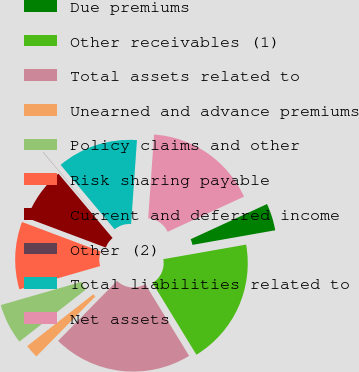Convert chart. <chart><loc_0><loc_0><loc_500><loc_500><pie_chart><fcel>Due premiums<fcel>Other receivables (1)<fcel>Total assets related to<fcel>Unearned and advance premiums<fcel>Policy claims and other<fcel>Risk sharing payable<fcel>Current and deferred income<fcel>Other (2)<fcel>Total liabilities related to<fcel>Net assets<nl><fcel>4.09%<fcel>19.05%<fcel>21.08%<fcel>2.06%<fcel>6.12%<fcel>10.18%<fcel>8.15%<fcel>0.03%<fcel>12.21%<fcel>17.02%<nl></chart> 